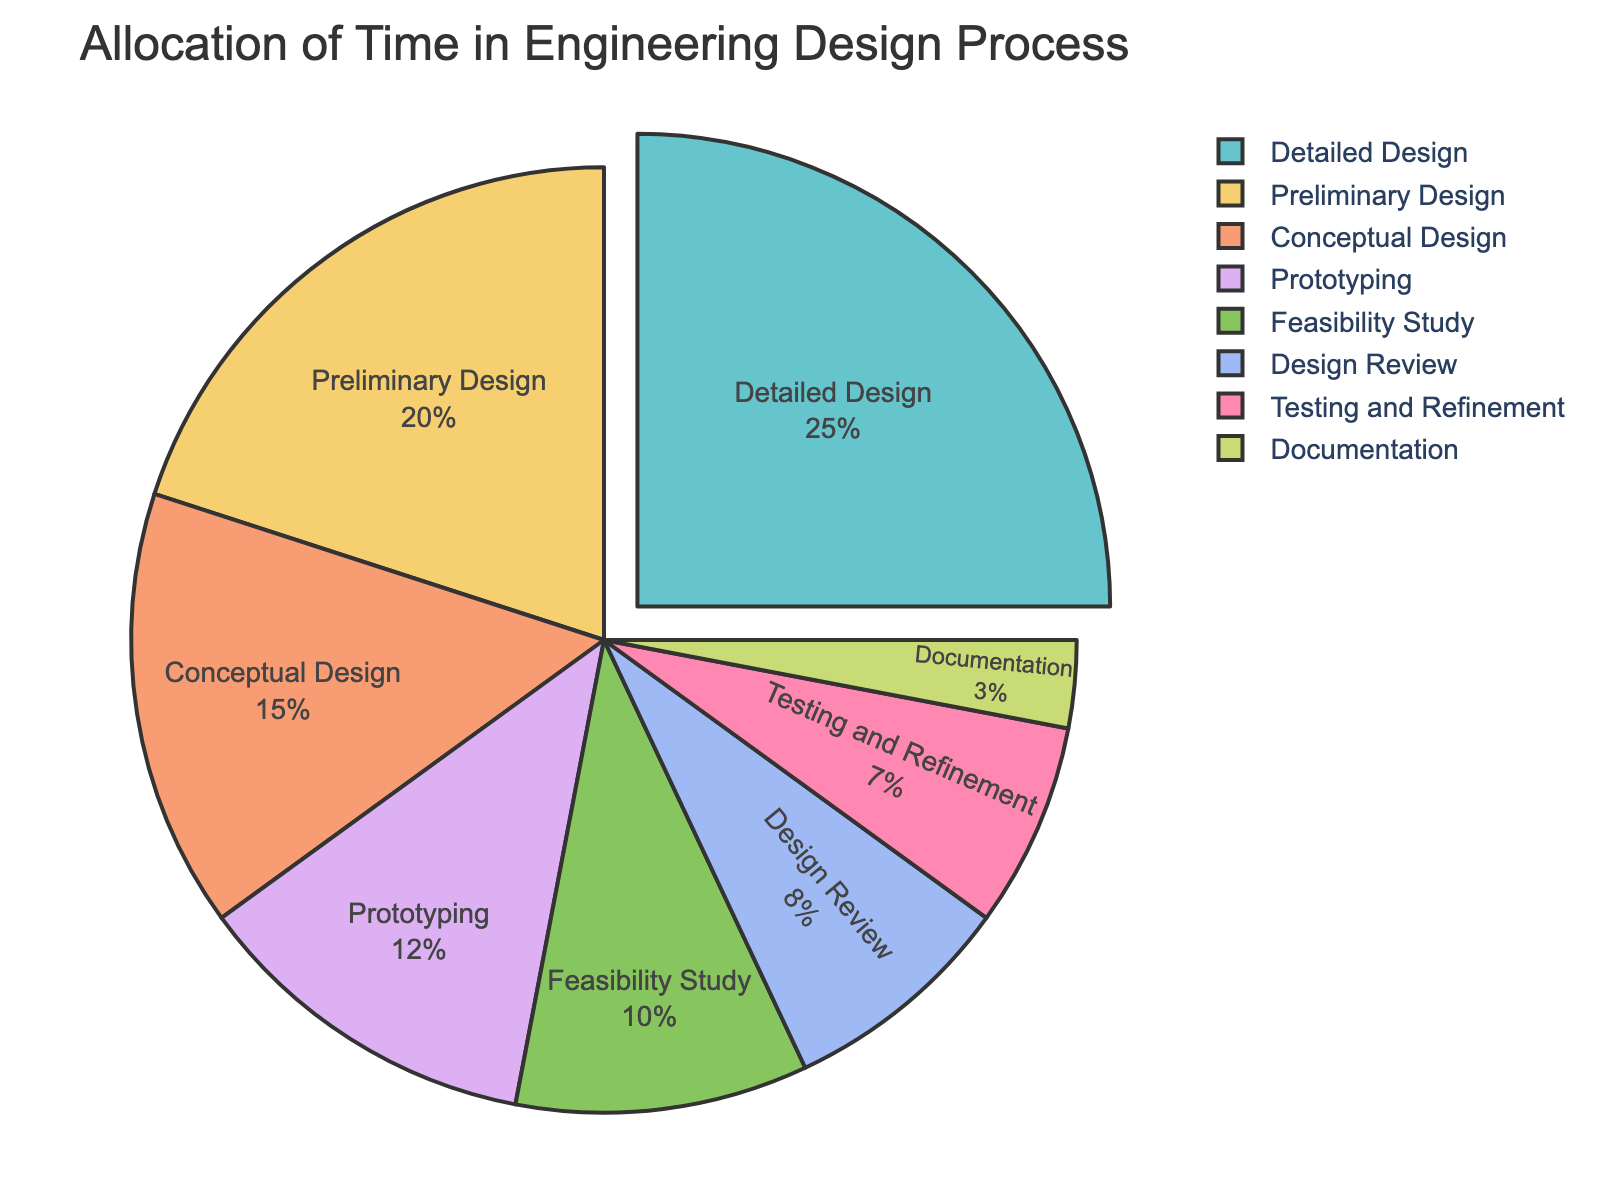Which stage takes up the largest portion of the time allocation? By observing the pie chart, the slice representing the "Detailed Design" stage is the largest compared to others. This can be identified visually as it occupies the most area in the chart.
Answer: Detailed Design What is the total percentage of time spent on the "Design Review" and "Prototyping"? From the chart, the "Design Review" stage takes 8% of the time, and "Prototyping" takes 12%. Adding these together, 8 + 12 = 20.
Answer: 20% How much more time is spent on the "Preliminary Design" compared to "Feasibility Study"? The "Preliminary Design" stage is allocated 20%, and the "Feasibility Study" is allocated 10%. The difference can be calculated as 20 - 10 = 10.
Answer: 10% What is the combined percentage of time spent on "Preliminary Design" and "Detailed Design"? The "Preliminary Design" stage takes 20% and the "Detailed Design" stage takes 25%. Adding these together, 20 + 25 = 45.
Answer: 45% Which stages together constitute more than half of the total allocation time? The "Detailed Design" (25%) and "Preliminary Design" (20%) together make 25 + 20 = 45%. Including "Conceptual Design" which is 15%, we get 45 + 15 = 60%, which is more than half. First, identify the largest blocks and add them up until the sum exceeds 50%.
Answer: Detailed Design, Preliminary Design, Conceptual Design Which stage takes up the smallest portion of the time allocation? The smallest slice in the pie chart represents the "Documentation" stage. This can be identified visually as it occupies the least amount of space.
Answer: Documentation By how much does the time allocation for "Detailed Design" exceed the combined allocations for "Testing and Refinement" and "Documentation"? The "Detailed Design" stage takes up 25%. The combined time for "Testing and Refinement" (7%) and "Documentation" (3%) is 7 + 3 = 10%. The difference is 25 - 10 = 15%.
Answer: 15% Which stages have a nearly similar allocation of time? The pie chart shows "Prototyping" at 12% and "Feasibility Study" at 10%, which are relatively close in value. "Design Review" at 8% and "Testing and Refinement" at 7% are also close. Identify similarly sized slices.
Answer: Prototyping and Feasibility Study; Design Review and Testing and Refinement 